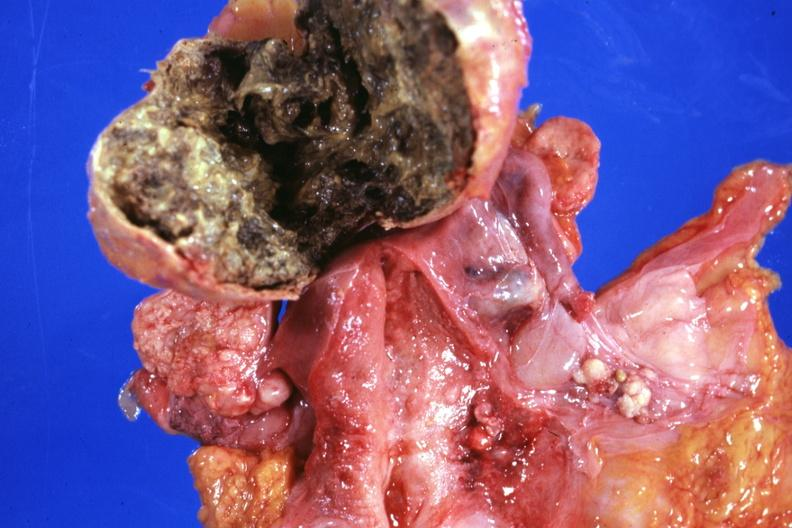what is present?
Answer the question using a single word or phrase. Benign cystic teratoma 